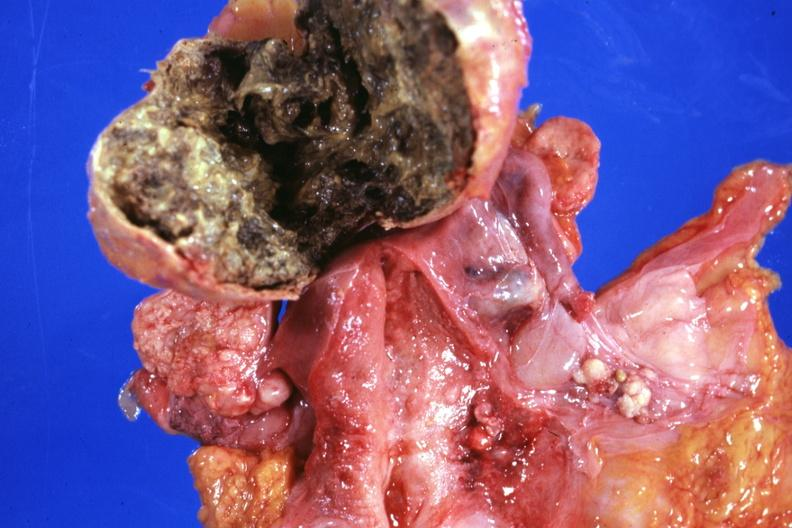what is present?
Answer the question using a single word or phrase. Benign cystic teratoma 